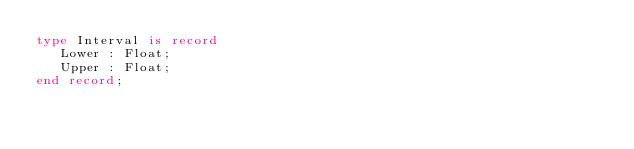Convert code to text. <code><loc_0><loc_0><loc_500><loc_500><_Ada_>type Interval is record
   Lower : Float;
   Upper : Float;
end record;
</code> 